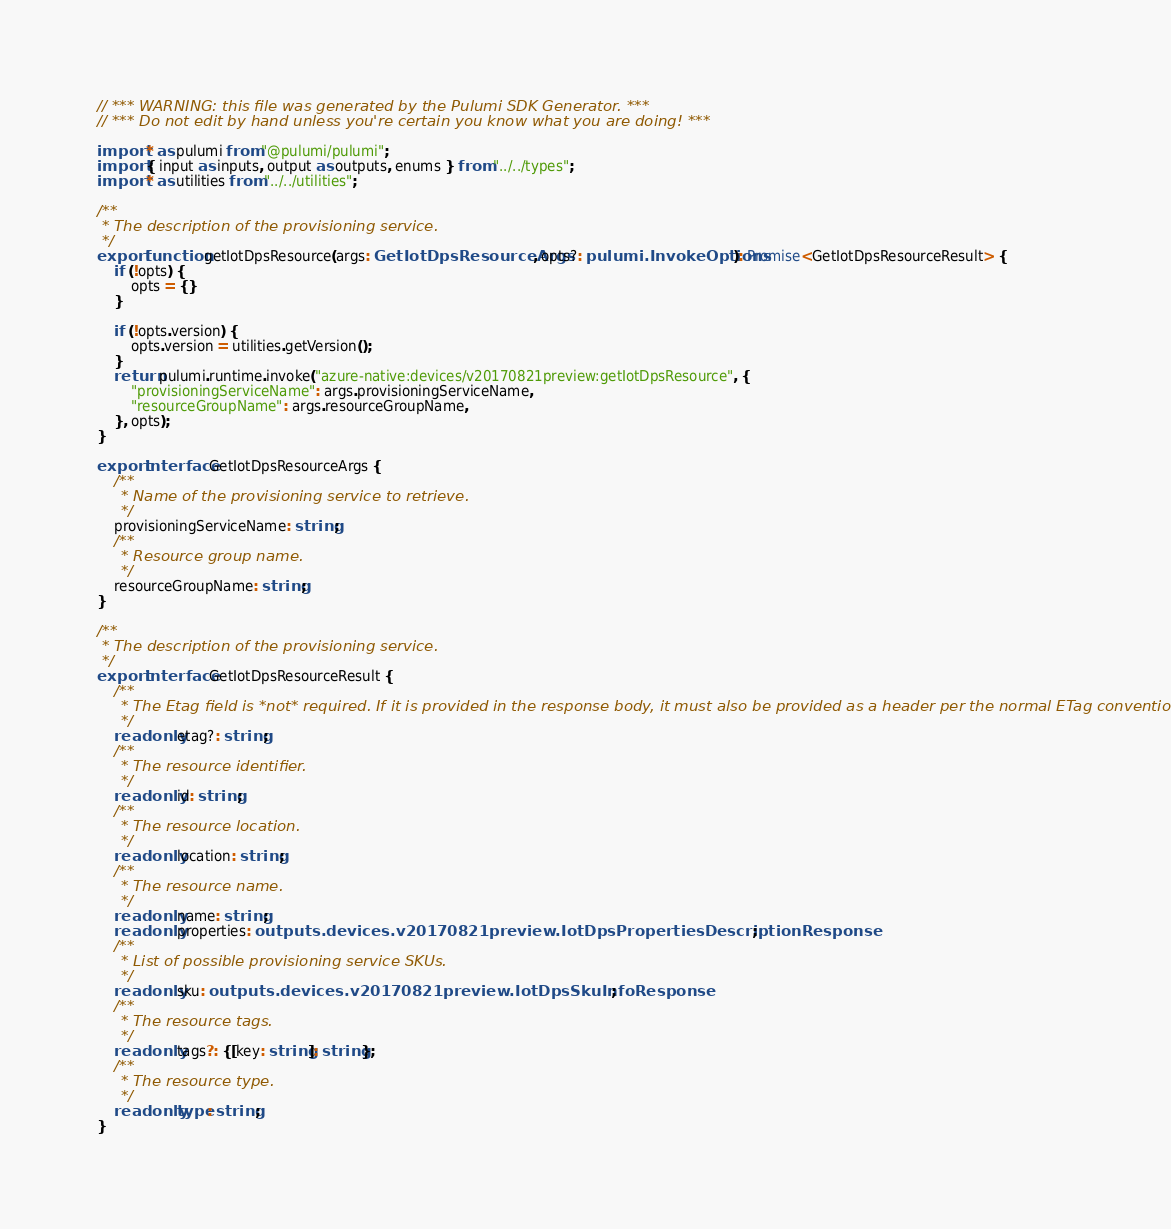Convert code to text. <code><loc_0><loc_0><loc_500><loc_500><_TypeScript_>// *** WARNING: this file was generated by the Pulumi SDK Generator. ***
// *** Do not edit by hand unless you're certain you know what you are doing! ***

import * as pulumi from "@pulumi/pulumi";
import { input as inputs, output as outputs, enums } from "../../types";
import * as utilities from "../../utilities";

/**
 * The description of the provisioning service.
 */
export function getIotDpsResource(args: GetIotDpsResourceArgs, opts?: pulumi.InvokeOptions): Promise<GetIotDpsResourceResult> {
    if (!opts) {
        opts = {}
    }

    if (!opts.version) {
        opts.version = utilities.getVersion();
    }
    return pulumi.runtime.invoke("azure-native:devices/v20170821preview:getIotDpsResource", {
        "provisioningServiceName": args.provisioningServiceName,
        "resourceGroupName": args.resourceGroupName,
    }, opts);
}

export interface GetIotDpsResourceArgs {
    /**
     * Name of the provisioning service to retrieve.
     */
    provisioningServiceName: string;
    /**
     * Resource group name.
     */
    resourceGroupName: string;
}

/**
 * The description of the provisioning service.
 */
export interface GetIotDpsResourceResult {
    /**
     * The Etag field is *not* required. If it is provided in the response body, it must also be provided as a header per the normal ETag convention.
     */
    readonly etag?: string;
    /**
     * The resource identifier.
     */
    readonly id: string;
    /**
     * The resource location.
     */
    readonly location: string;
    /**
     * The resource name.
     */
    readonly name: string;
    readonly properties: outputs.devices.v20170821preview.IotDpsPropertiesDescriptionResponse;
    /**
     * List of possible provisioning service SKUs.
     */
    readonly sku: outputs.devices.v20170821preview.IotDpsSkuInfoResponse;
    /**
     * The resource tags.
     */
    readonly tags?: {[key: string]: string};
    /**
     * The resource type.
     */
    readonly type: string;
}
</code> 